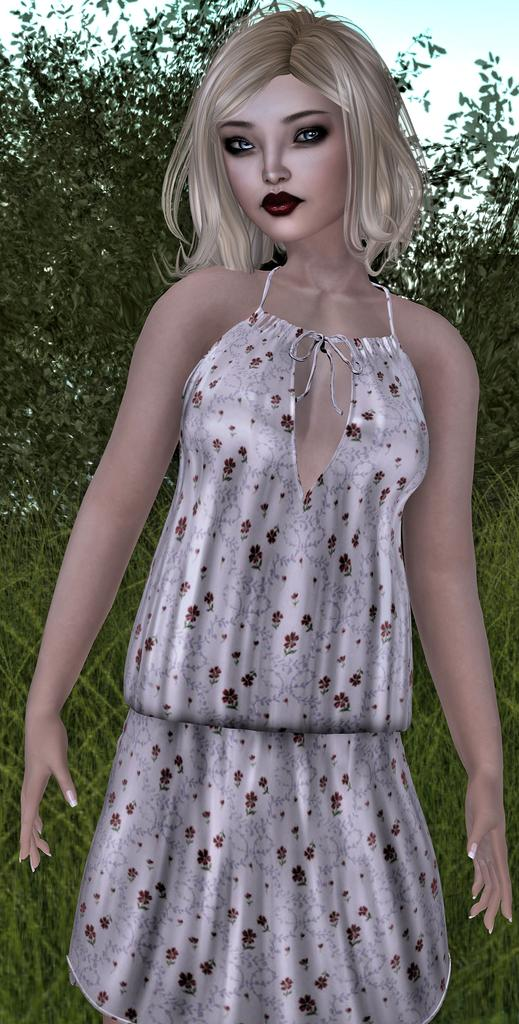Who or what is the main subject of the image? There is a person depicted in the image. What can be observed about the person's attire? The person is wearing clothes. What type of natural environment is visible in the background of the image? There are trees and grass in the background of the image. What color is the person's head in the image? The provided facts do not mention the color of the person's head, and there is no indication that the person's head is a different color than the rest of their body. 